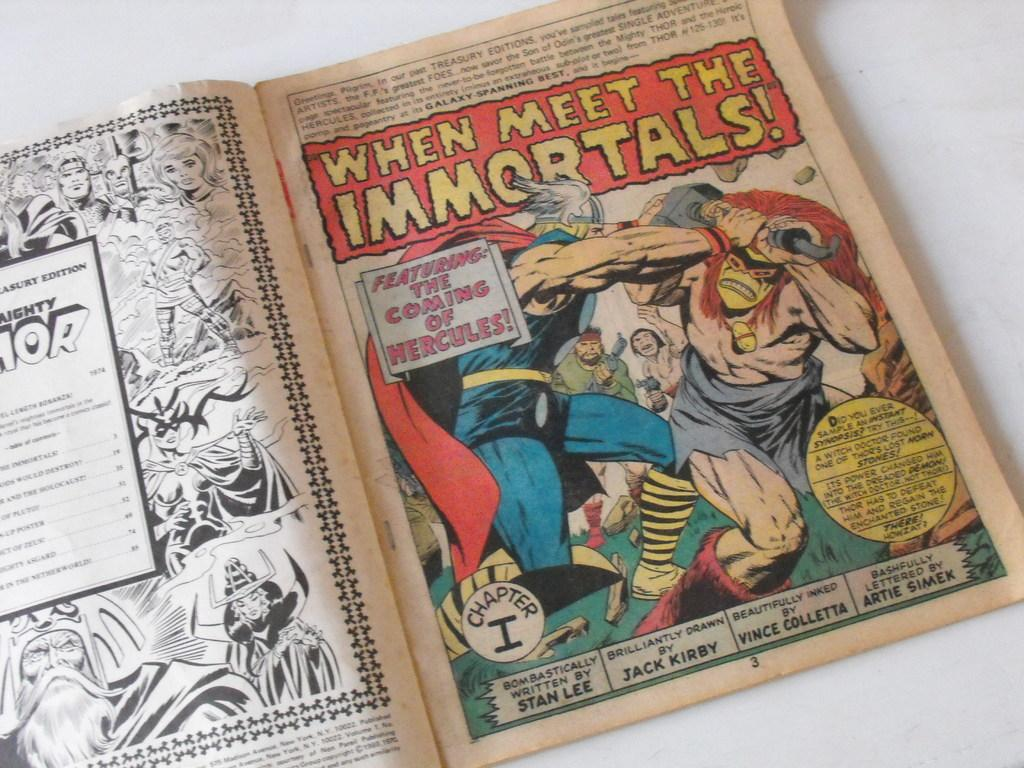<image>
Present a compact description of the photo's key features. the words when meet the immortals is on the comic 